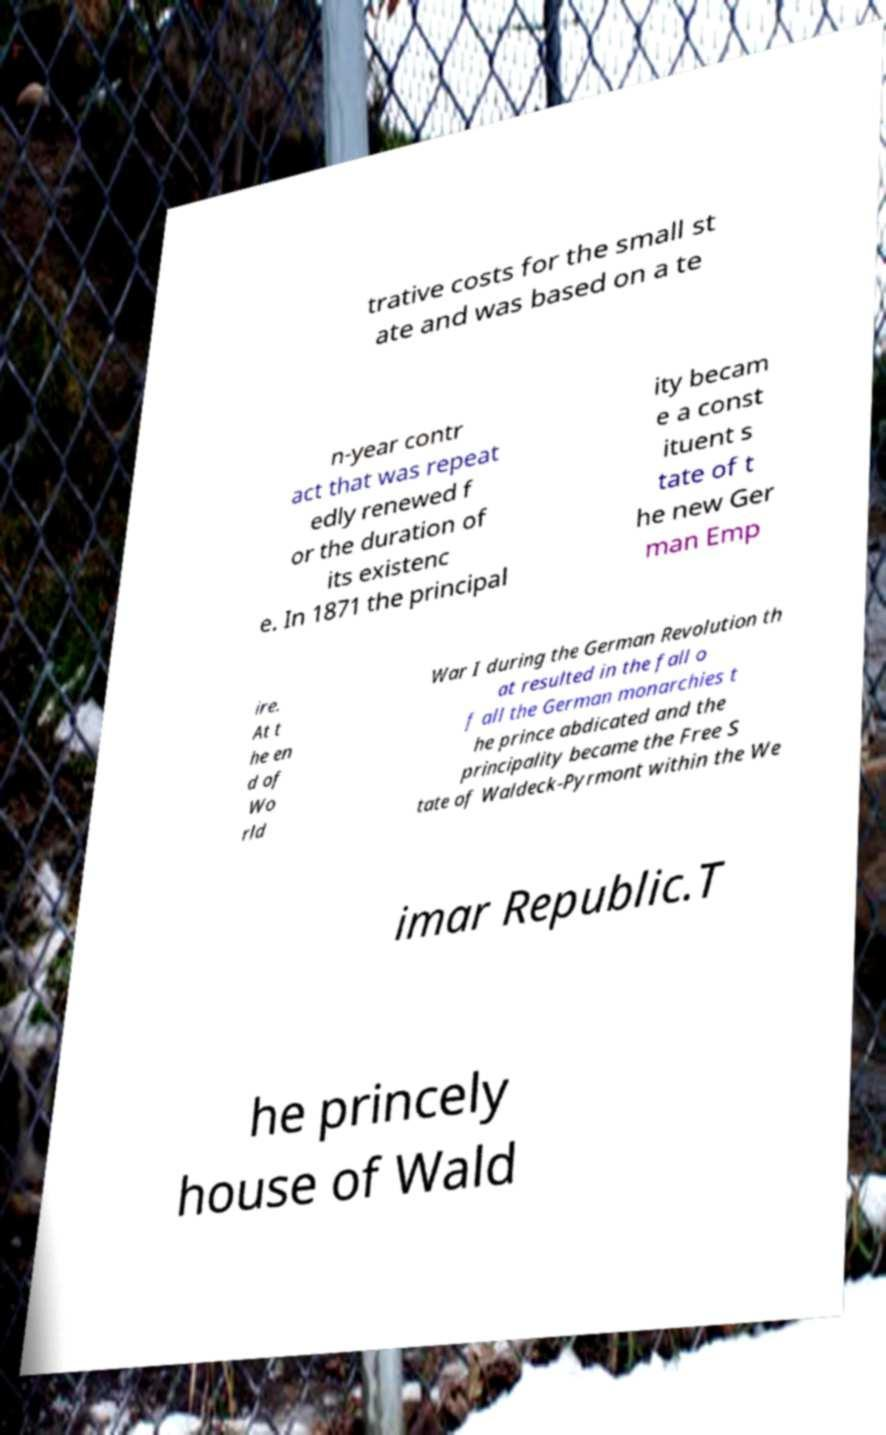I need the written content from this picture converted into text. Can you do that? trative costs for the small st ate and was based on a te n-year contr act that was repeat edly renewed f or the duration of its existenc e. In 1871 the principal ity becam e a const ituent s tate of t he new Ger man Emp ire. At t he en d of Wo rld War I during the German Revolution th at resulted in the fall o f all the German monarchies t he prince abdicated and the principality became the Free S tate of Waldeck-Pyrmont within the We imar Republic.T he princely house of Wald 